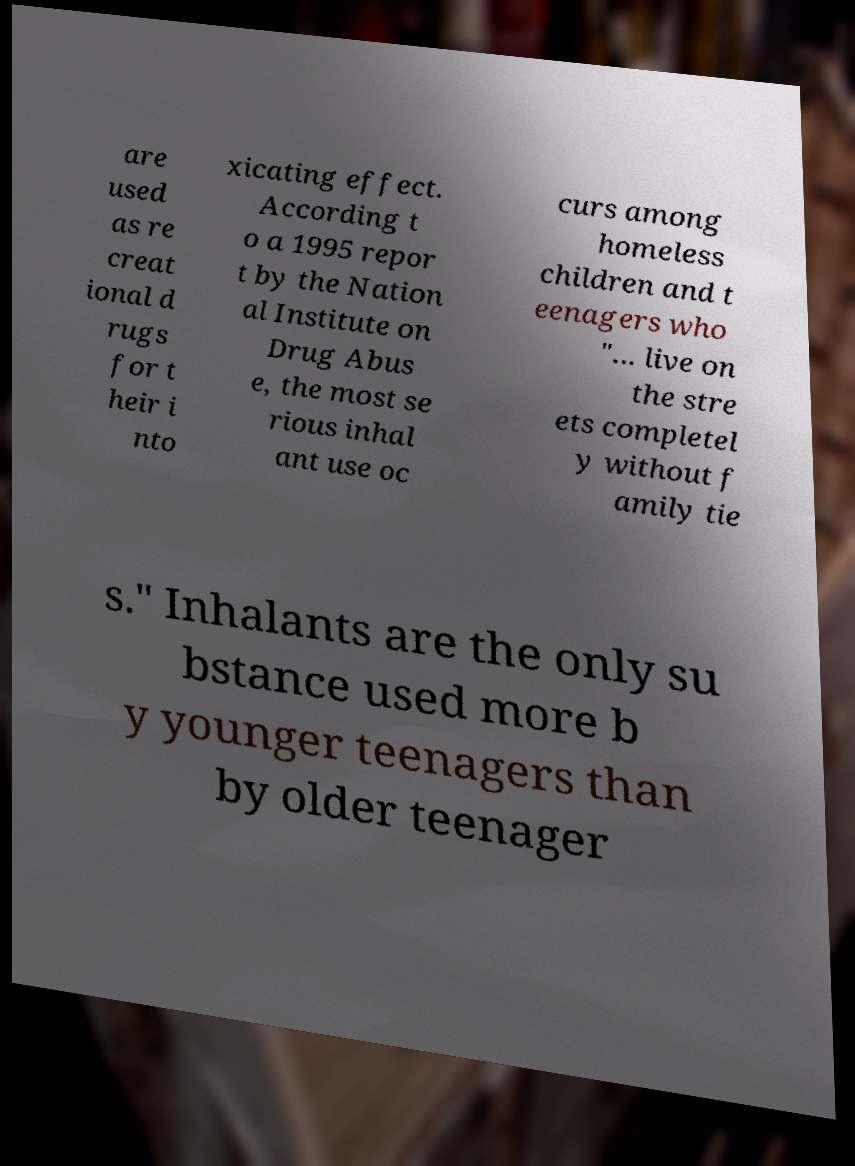Can you accurately transcribe the text from the provided image for me? are used as re creat ional d rugs for t heir i nto xicating effect. According t o a 1995 repor t by the Nation al Institute on Drug Abus e, the most se rious inhal ant use oc curs among homeless children and t eenagers who "... live on the stre ets completel y without f amily tie s." Inhalants are the only su bstance used more b y younger teenagers than by older teenager 